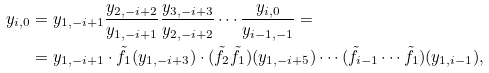Convert formula to latex. <formula><loc_0><loc_0><loc_500><loc_500>y _ { i , 0 } & = y _ { 1 , - i + 1 } \frac { y _ { 2 , - i + 2 } } { y _ { 1 , - i + 1 } } \frac { y _ { 3 , - i + 3 } } { y _ { 2 , - i + 2 } } \cdots \frac { y _ { i , 0 } } { y _ { i - 1 , - 1 } } = \\ & = y _ { 1 , - i + 1 } \cdot \tilde { f } _ { 1 } ( y _ { 1 , - i + 3 } ) \cdot ( \tilde { f } _ { 2 } \tilde { f } _ { 1 } ) ( y _ { 1 , - i + 5 } ) \cdots ( \tilde { f } _ { i - 1 } \cdots \tilde { f } _ { 1 } ) ( y _ { 1 , i - 1 } ) ,</formula> 